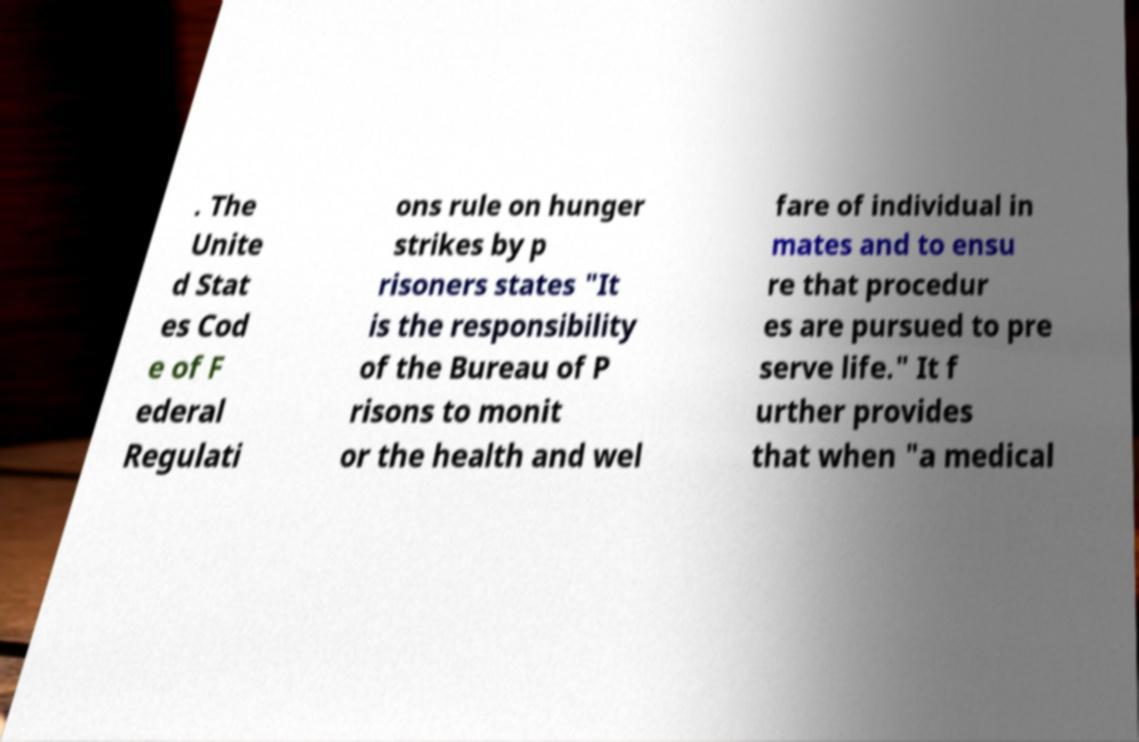Could you extract and type out the text from this image? . The Unite d Stat es Cod e of F ederal Regulati ons rule on hunger strikes by p risoners states "It is the responsibility of the Bureau of P risons to monit or the health and wel fare of individual in mates and to ensu re that procedur es are pursued to pre serve life." It f urther provides that when "a medical 